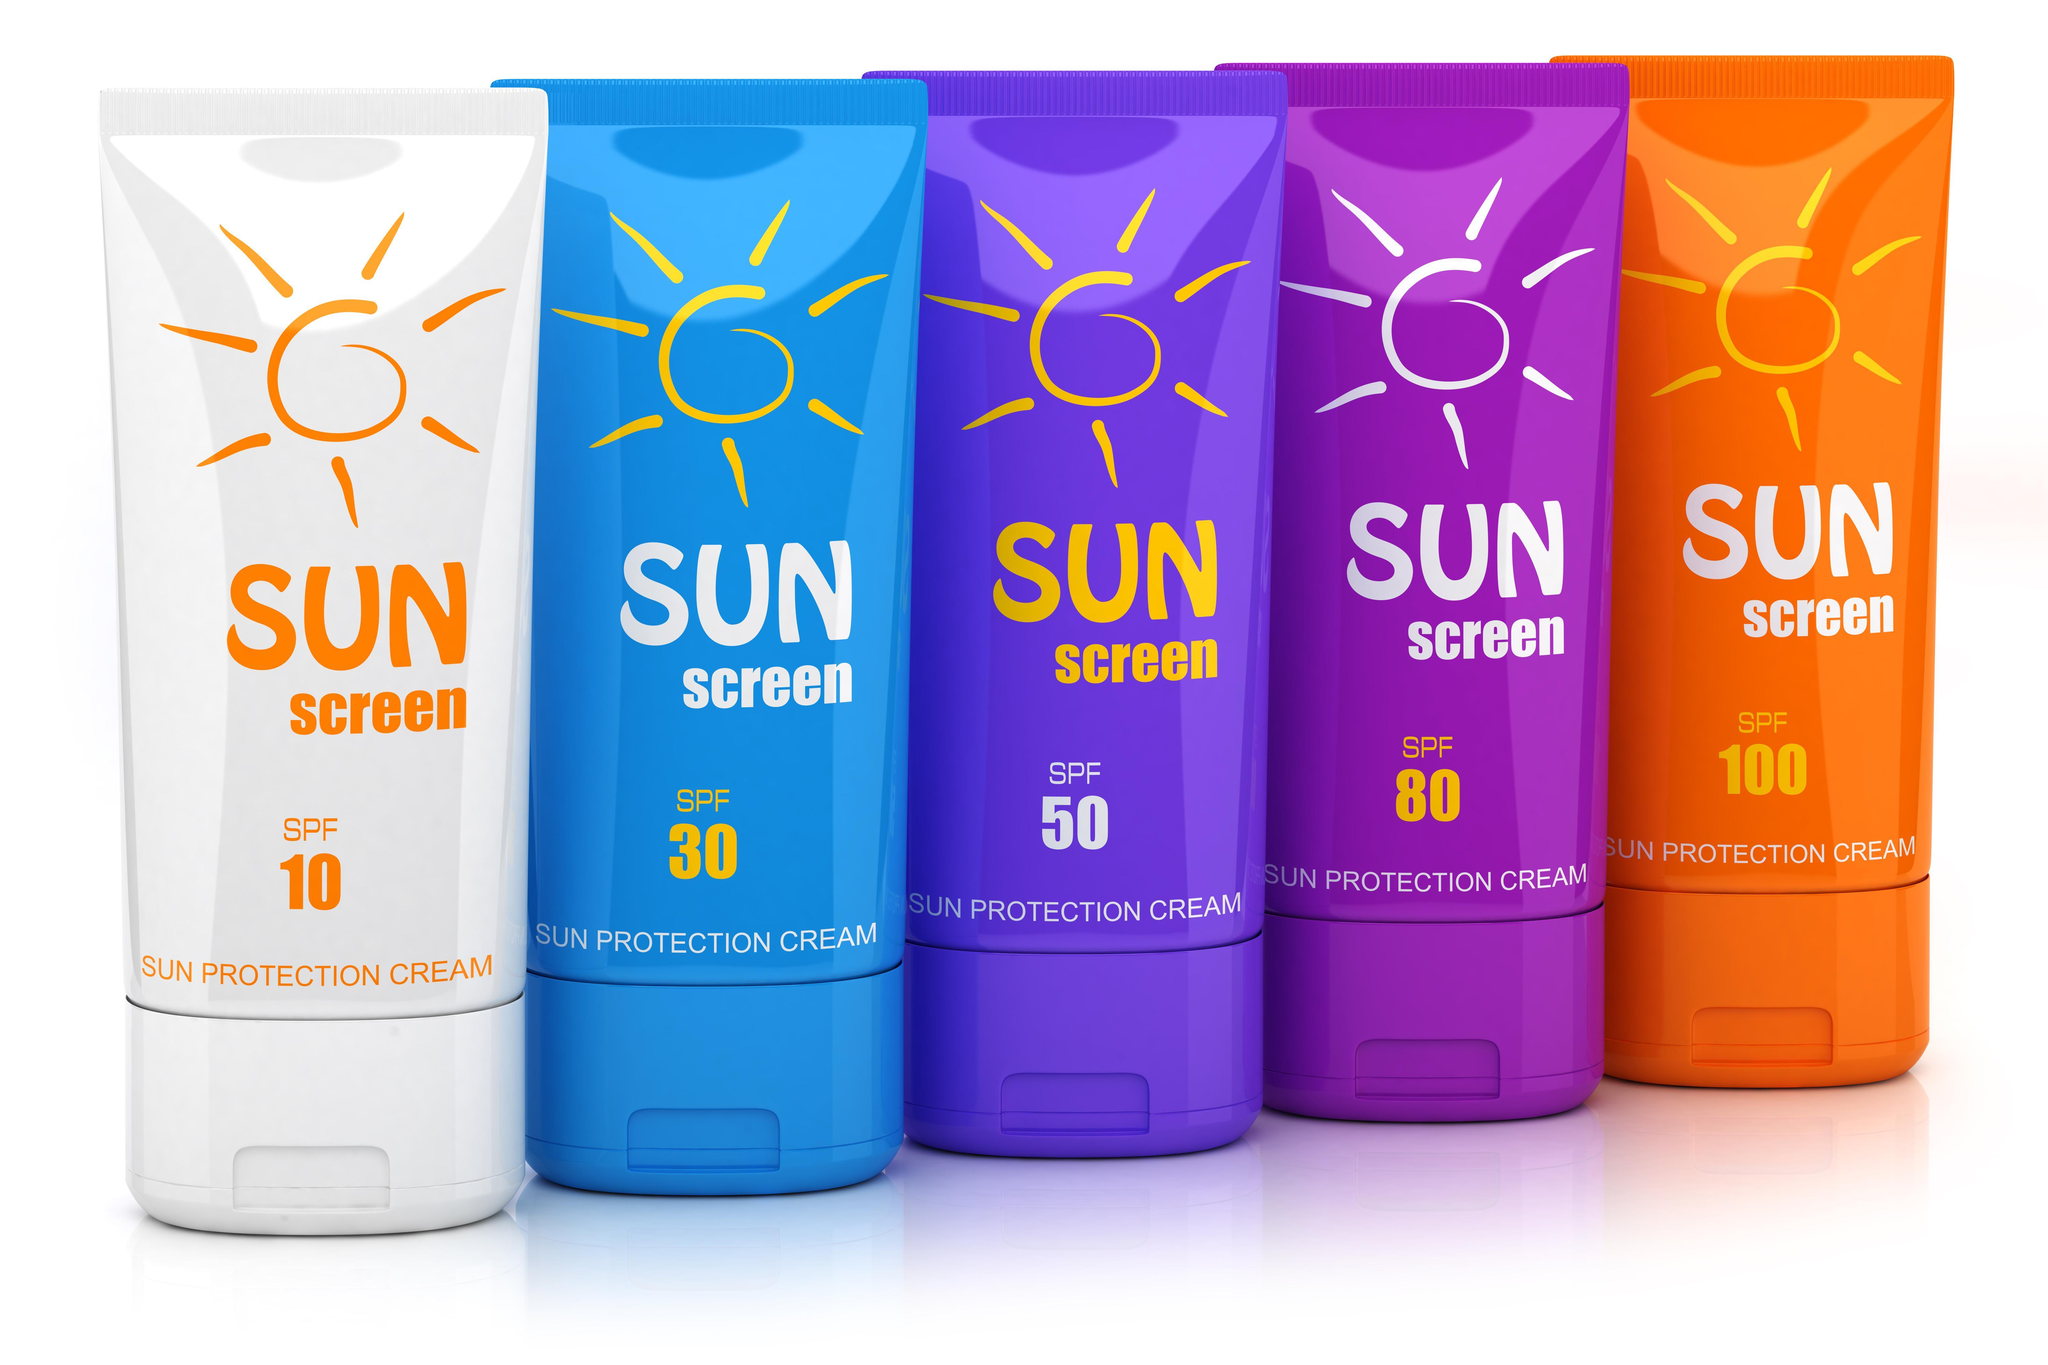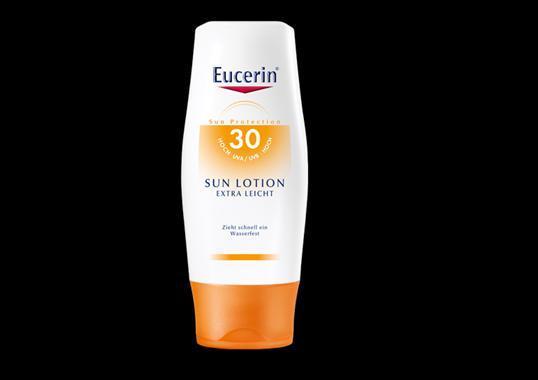The first image is the image on the left, the second image is the image on the right. Evaluate the accuracy of this statement regarding the images: "The left image contains at least two ointment containers.". Is it true? Answer yes or no. Yes. The first image is the image on the left, the second image is the image on the right. For the images displayed, is the sentence "The left image contains no more than two skincare products, and includes at least one pump-top bottle with its nozzle facing rightward." factually correct? Answer yes or no. No. 